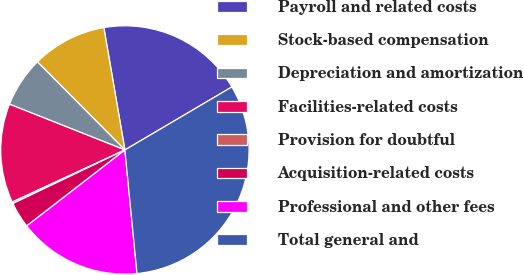Convert chart to OTSL. <chart><loc_0><loc_0><loc_500><loc_500><pie_chart><fcel>Payroll and related costs<fcel>Stock-based compensation<fcel>Depreciation and amortization<fcel>Facilities-related costs<fcel>Provision for doubtful<fcel>Acquisition-related costs<fcel>Professional and other fees<fcel>Total general and<nl><fcel>19.24%<fcel>9.73%<fcel>6.55%<fcel>12.9%<fcel>0.21%<fcel>3.38%<fcel>16.07%<fcel>31.92%<nl></chart> 